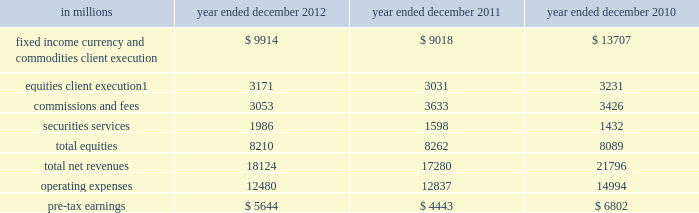Management 2019s discussion and analysis the table below presents the operating results of our institutional client services segment. .
Includes net revenues related to reinsurance of $ 1.08 billion , $ 880 million and $ 827 million for the years ended december 2012 , december 2011 and december 2010 , respectively .
2012 versus 2011 .
Net revenues in institutional client services were $ 18.12 billion for 2012 , 5% ( 5 % ) higher than 2011 .
Net revenues in fixed income , currency and commodities client execution were $ 9.91 billion for 2012 , 10% ( 10 % ) higher than 2011 .
These results reflected strong net revenues in mortgages , which were significantly higher compared with 2011 .
In addition , net revenues in credit products and interest rate products were solid and higher compared with 2011 .
These increases were partially offset by significantly lower net revenues in commodities and slightly lower net revenues in currencies .
Although broad market concerns persisted during 2012 , fixed income , currency and commodities client execution operated in a generally improved environment characterized by tighter credit spreads and less challenging market-making conditions compared with 2011 .
Net revenues in equities were $ 8.21 billion for 2012 , essentially unchanged compared with 2011 .
Net revenues in securities services were significantly higher compared with 2011 , reflecting a gain of approximately $ 500 million on the sale of our hedge fund administration business .
In addition , equities client execution net revenues were higher than 2011 , primarily reflecting significantly higher results in cash products , principally due to increased levels of client activity .
These increases were offset by lower commissions and fees , reflecting lower market volumes .
During 2012 , equities operated in an environment generally characterized by an increase in global equity prices and lower volatility levels .
The net loss attributable to the impact of changes in our own credit spreads on borrowings for which the fair value option was elected was $ 714 million ( $ 433 million and $ 281 million related to fixed income , currency and commodities client execution and equities client execution , respectively ) for 2012 , compared with a net gain of $ 596 million ( $ 399 million and $ 197 million related to fixed income , currency and commodities client execution and equities client execution , respectively ) for 2011 .
During 2012 , institutional client services operated in an environment generally characterized by continued broad market concerns and uncertainties , although positive developments helped to improve market conditions .
These developments included certain central bank actions to ease monetary policy and address funding risks for european financial institutions .
In addition , the u.s .
Economy posted stable to improving economic data , including favorable developments in unemployment and housing .
These improvements resulted in tighter credit spreads , higher global equity prices and lower levels of volatility .
However , concerns about the outlook for the global economy and continued political uncertainty , particularly the political debate in the united states surrounding the fiscal cliff , generally resulted in client risk aversion and lower activity levels .
Also , uncertainty over financial regulatory reform persisted .
If these concerns and uncertainties continue over the long term , net revenues in fixed income , currency and commodities client execution and equities would likely be negatively impacted .
Operating expenses were $ 12.48 billion for 2012 , 3% ( 3 % ) lower than 2011 , primarily due to lower brokerage , clearing , exchange and distribution fees , and lower impairment charges , partially offset by higher net provisions for litigation and regulatory proceedings .
Pre-tax earnings were $ 5.64 billion in 2012 , 27% ( 27 % ) higher than 2011 .
2011 versus 2010 .
Net revenues in institutional client services were $ 17.28 billion for 2011 , 21% ( 21 % ) lower than 2010 .
Net revenues in fixed income , currency and commodities client execution were $ 9.02 billion for 2011 , 34% ( 34 % ) lower than 2010 .
Although activity levels during 2011 were generally consistent with 2010 levels , and results were solid during the first quarter of 2011 , the environment during the remainder of 2011 was characterized by broad market concerns and uncertainty , resulting in volatile markets and significantly wider credit spreads , which contributed to difficult market-making conditions and led to reductions in risk by us and our clients .
As a result of these conditions , net revenues across the franchise were lower , including significant declines in mortgages and credit products , compared with 2010 .
54 goldman sachs 2012 annual report .
What is the growth rate in pre-tax earnings in 2011? 
Computations: ((4443 - 6802) / 6802)
Answer: -0.34681. 